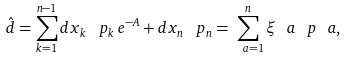Convert formula to latex. <formula><loc_0><loc_0><loc_500><loc_500>\hat { d } = \sum _ { k = 1 } ^ { n - 1 } d x _ { k } \, \ p _ { k } \, e ^ { - A } + d x _ { n } \, \ p _ { n } = \sum _ { \ a = 1 } ^ { n } \xi _ { \ } a \, \ p _ { \ } a ,</formula> 